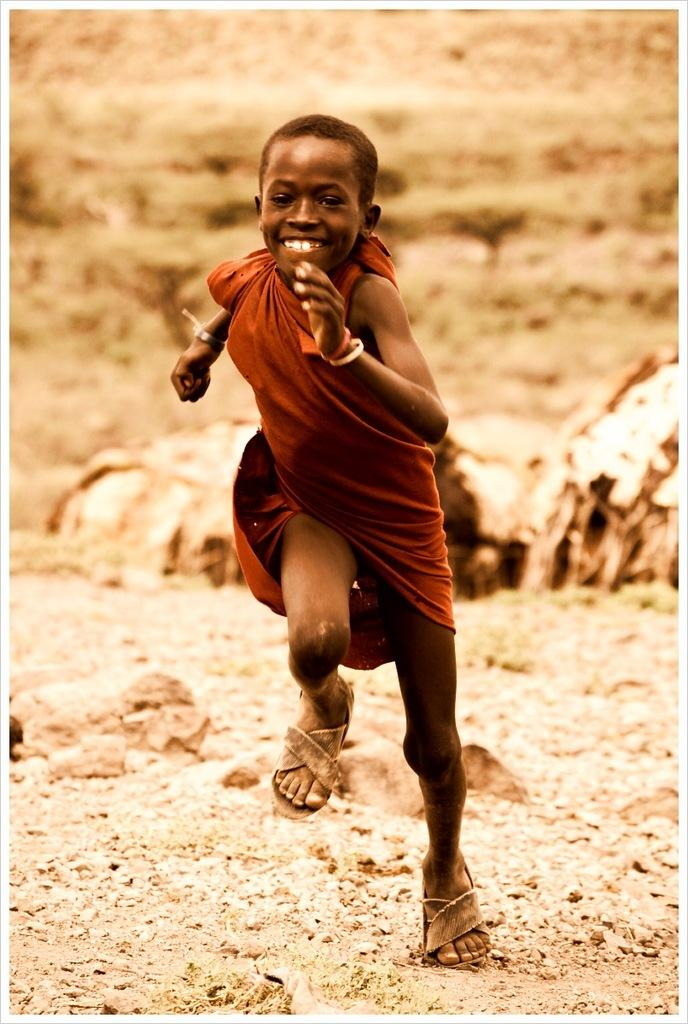Who is the main subject in the image? There is a child in the image. What is the child wearing? The child is wearing a brown color cloth. What is the child doing in the image? The child is running. Can you describe the background of the image? The background of the image is blurred. Is the girl driving a car in the image? There is no girl or car present in the image; it features a child running. What type of thrill can be seen in the child's face in the image? The image does not show the child's face, so it is not possible to determine the expression or any associated thrill. 